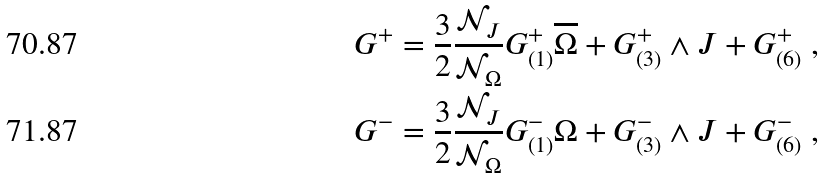<formula> <loc_0><loc_0><loc_500><loc_500>G ^ { + } & = \frac { 3 } { 2 } \frac { \mathcal { N } _ { J } } { \mathcal { N } _ { \Omega } } G _ { ( 1 ) } ^ { + } \overline { \Omega } + G _ { ( 3 ) } ^ { + } \wedge J + G _ { ( 6 ) } ^ { + } \ , \\ G ^ { - } & = \frac { 3 } { 2 } \frac { \mathcal { N } _ { J } } { \mathcal { N } _ { \Omega } } G _ { ( 1 ) } ^ { - } \Omega + G _ { ( 3 ) } ^ { - } \wedge J + G _ { ( 6 ) } ^ { - } \ ,</formula> 